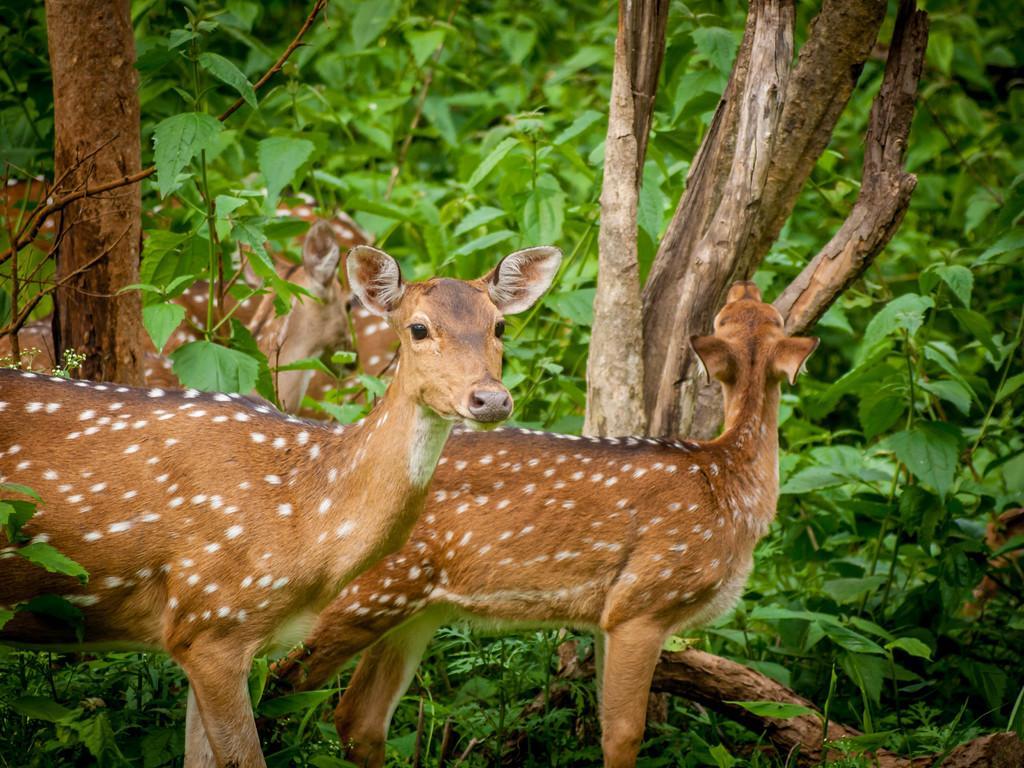Can you describe this image briefly? In front of the image there are two deer. Behind them there are many trees and also there is a herd of deer. 